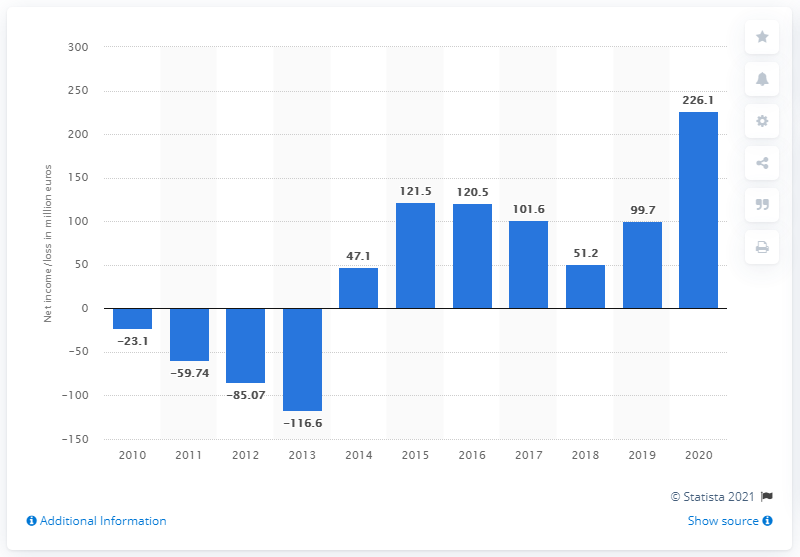Outline some significant characteristics in this image. In 2020, Zalando's net income was 226.1 million euros. Zalando's net income in the previous year was 99.7 million euros. 